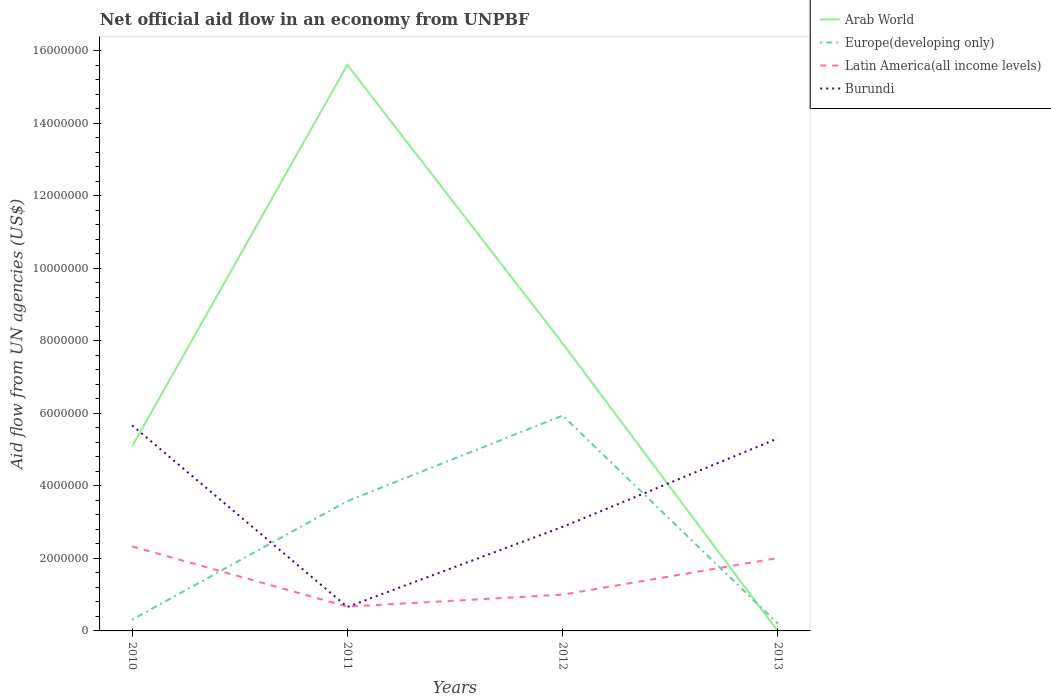Across all years, what is the maximum net official aid flow in Burundi?
Offer a terse response. 6.60e+05. What is the total net official aid flow in Arab World in the graph?
Ensure brevity in your answer.  7.68e+06. What is the difference between the highest and the second highest net official aid flow in Latin America(all income levels)?
Give a very brief answer. 1.66e+06. Is the net official aid flow in Burundi strictly greater than the net official aid flow in Latin America(all income levels) over the years?
Offer a very short reply. No. How many years are there in the graph?
Make the answer very short. 4. Where does the legend appear in the graph?
Keep it short and to the point. Top right. What is the title of the graph?
Provide a short and direct response. Net official aid flow in an economy from UNPBF. What is the label or title of the Y-axis?
Offer a terse response. Aid flow from UN agencies (US$). What is the Aid flow from UN agencies (US$) of Arab World in 2010?
Provide a short and direct response. 5.09e+06. What is the Aid flow from UN agencies (US$) of Europe(developing only) in 2010?
Provide a short and direct response. 3.10e+05. What is the Aid flow from UN agencies (US$) of Latin America(all income levels) in 2010?
Your answer should be very brief. 2.33e+06. What is the Aid flow from UN agencies (US$) of Burundi in 2010?
Your answer should be compact. 5.67e+06. What is the Aid flow from UN agencies (US$) of Arab World in 2011?
Ensure brevity in your answer.  1.56e+07. What is the Aid flow from UN agencies (US$) in Europe(developing only) in 2011?
Keep it short and to the point. 3.58e+06. What is the Aid flow from UN agencies (US$) in Latin America(all income levels) in 2011?
Your answer should be compact. 6.70e+05. What is the Aid flow from UN agencies (US$) of Burundi in 2011?
Give a very brief answer. 6.60e+05. What is the Aid flow from UN agencies (US$) of Arab World in 2012?
Provide a short and direct response. 7.93e+06. What is the Aid flow from UN agencies (US$) in Europe(developing only) in 2012?
Your response must be concise. 5.94e+06. What is the Aid flow from UN agencies (US$) in Latin America(all income levels) in 2012?
Keep it short and to the point. 1.00e+06. What is the Aid flow from UN agencies (US$) of Burundi in 2012?
Your response must be concise. 2.87e+06. What is the Aid flow from UN agencies (US$) of Europe(developing only) in 2013?
Your answer should be very brief. 2.00e+05. What is the Aid flow from UN agencies (US$) of Latin America(all income levels) in 2013?
Your answer should be very brief. 2.01e+06. What is the Aid flow from UN agencies (US$) in Burundi in 2013?
Make the answer very short. 5.31e+06. Across all years, what is the maximum Aid flow from UN agencies (US$) of Arab World?
Provide a succinct answer. 1.56e+07. Across all years, what is the maximum Aid flow from UN agencies (US$) in Europe(developing only)?
Your response must be concise. 5.94e+06. Across all years, what is the maximum Aid flow from UN agencies (US$) in Latin America(all income levels)?
Make the answer very short. 2.33e+06. Across all years, what is the maximum Aid flow from UN agencies (US$) of Burundi?
Keep it short and to the point. 5.67e+06. Across all years, what is the minimum Aid flow from UN agencies (US$) of Latin America(all income levels)?
Ensure brevity in your answer.  6.70e+05. Across all years, what is the minimum Aid flow from UN agencies (US$) in Burundi?
Your answer should be compact. 6.60e+05. What is the total Aid flow from UN agencies (US$) in Arab World in the graph?
Provide a succinct answer. 2.86e+07. What is the total Aid flow from UN agencies (US$) of Europe(developing only) in the graph?
Your answer should be compact. 1.00e+07. What is the total Aid flow from UN agencies (US$) of Latin America(all income levels) in the graph?
Offer a very short reply. 6.01e+06. What is the total Aid flow from UN agencies (US$) in Burundi in the graph?
Offer a very short reply. 1.45e+07. What is the difference between the Aid flow from UN agencies (US$) of Arab World in 2010 and that in 2011?
Your answer should be very brief. -1.05e+07. What is the difference between the Aid flow from UN agencies (US$) in Europe(developing only) in 2010 and that in 2011?
Give a very brief answer. -3.27e+06. What is the difference between the Aid flow from UN agencies (US$) in Latin America(all income levels) in 2010 and that in 2011?
Provide a short and direct response. 1.66e+06. What is the difference between the Aid flow from UN agencies (US$) in Burundi in 2010 and that in 2011?
Provide a succinct answer. 5.01e+06. What is the difference between the Aid flow from UN agencies (US$) of Arab World in 2010 and that in 2012?
Provide a succinct answer. -2.84e+06. What is the difference between the Aid flow from UN agencies (US$) in Europe(developing only) in 2010 and that in 2012?
Your answer should be compact. -5.63e+06. What is the difference between the Aid flow from UN agencies (US$) in Latin America(all income levels) in 2010 and that in 2012?
Your response must be concise. 1.33e+06. What is the difference between the Aid flow from UN agencies (US$) of Burundi in 2010 and that in 2012?
Offer a very short reply. 2.80e+06. What is the difference between the Aid flow from UN agencies (US$) of Europe(developing only) in 2010 and that in 2013?
Your answer should be compact. 1.10e+05. What is the difference between the Aid flow from UN agencies (US$) of Latin America(all income levels) in 2010 and that in 2013?
Provide a succinct answer. 3.20e+05. What is the difference between the Aid flow from UN agencies (US$) of Arab World in 2011 and that in 2012?
Offer a terse response. 7.68e+06. What is the difference between the Aid flow from UN agencies (US$) of Europe(developing only) in 2011 and that in 2012?
Make the answer very short. -2.36e+06. What is the difference between the Aid flow from UN agencies (US$) in Latin America(all income levels) in 2011 and that in 2012?
Your answer should be very brief. -3.30e+05. What is the difference between the Aid flow from UN agencies (US$) in Burundi in 2011 and that in 2012?
Ensure brevity in your answer.  -2.21e+06. What is the difference between the Aid flow from UN agencies (US$) of Europe(developing only) in 2011 and that in 2013?
Make the answer very short. 3.38e+06. What is the difference between the Aid flow from UN agencies (US$) of Latin America(all income levels) in 2011 and that in 2013?
Give a very brief answer. -1.34e+06. What is the difference between the Aid flow from UN agencies (US$) in Burundi in 2011 and that in 2013?
Your answer should be compact. -4.65e+06. What is the difference between the Aid flow from UN agencies (US$) in Europe(developing only) in 2012 and that in 2013?
Offer a terse response. 5.74e+06. What is the difference between the Aid flow from UN agencies (US$) in Latin America(all income levels) in 2012 and that in 2013?
Your answer should be very brief. -1.01e+06. What is the difference between the Aid flow from UN agencies (US$) in Burundi in 2012 and that in 2013?
Your answer should be compact. -2.44e+06. What is the difference between the Aid flow from UN agencies (US$) in Arab World in 2010 and the Aid flow from UN agencies (US$) in Europe(developing only) in 2011?
Your answer should be compact. 1.51e+06. What is the difference between the Aid flow from UN agencies (US$) in Arab World in 2010 and the Aid flow from UN agencies (US$) in Latin America(all income levels) in 2011?
Provide a succinct answer. 4.42e+06. What is the difference between the Aid flow from UN agencies (US$) of Arab World in 2010 and the Aid flow from UN agencies (US$) of Burundi in 2011?
Your answer should be very brief. 4.43e+06. What is the difference between the Aid flow from UN agencies (US$) in Europe(developing only) in 2010 and the Aid flow from UN agencies (US$) in Latin America(all income levels) in 2011?
Give a very brief answer. -3.60e+05. What is the difference between the Aid flow from UN agencies (US$) of Europe(developing only) in 2010 and the Aid flow from UN agencies (US$) of Burundi in 2011?
Offer a very short reply. -3.50e+05. What is the difference between the Aid flow from UN agencies (US$) of Latin America(all income levels) in 2010 and the Aid flow from UN agencies (US$) of Burundi in 2011?
Offer a very short reply. 1.67e+06. What is the difference between the Aid flow from UN agencies (US$) of Arab World in 2010 and the Aid flow from UN agencies (US$) of Europe(developing only) in 2012?
Give a very brief answer. -8.50e+05. What is the difference between the Aid flow from UN agencies (US$) of Arab World in 2010 and the Aid flow from UN agencies (US$) of Latin America(all income levels) in 2012?
Offer a very short reply. 4.09e+06. What is the difference between the Aid flow from UN agencies (US$) in Arab World in 2010 and the Aid flow from UN agencies (US$) in Burundi in 2012?
Offer a terse response. 2.22e+06. What is the difference between the Aid flow from UN agencies (US$) of Europe(developing only) in 2010 and the Aid flow from UN agencies (US$) of Latin America(all income levels) in 2012?
Offer a terse response. -6.90e+05. What is the difference between the Aid flow from UN agencies (US$) of Europe(developing only) in 2010 and the Aid flow from UN agencies (US$) of Burundi in 2012?
Offer a terse response. -2.56e+06. What is the difference between the Aid flow from UN agencies (US$) in Latin America(all income levels) in 2010 and the Aid flow from UN agencies (US$) in Burundi in 2012?
Provide a succinct answer. -5.40e+05. What is the difference between the Aid flow from UN agencies (US$) of Arab World in 2010 and the Aid flow from UN agencies (US$) of Europe(developing only) in 2013?
Your response must be concise. 4.89e+06. What is the difference between the Aid flow from UN agencies (US$) of Arab World in 2010 and the Aid flow from UN agencies (US$) of Latin America(all income levels) in 2013?
Ensure brevity in your answer.  3.08e+06. What is the difference between the Aid flow from UN agencies (US$) of Arab World in 2010 and the Aid flow from UN agencies (US$) of Burundi in 2013?
Your response must be concise. -2.20e+05. What is the difference between the Aid flow from UN agencies (US$) in Europe(developing only) in 2010 and the Aid flow from UN agencies (US$) in Latin America(all income levels) in 2013?
Your answer should be compact. -1.70e+06. What is the difference between the Aid flow from UN agencies (US$) of Europe(developing only) in 2010 and the Aid flow from UN agencies (US$) of Burundi in 2013?
Your answer should be compact. -5.00e+06. What is the difference between the Aid flow from UN agencies (US$) in Latin America(all income levels) in 2010 and the Aid flow from UN agencies (US$) in Burundi in 2013?
Give a very brief answer. -2.98e+06. What is the difference between the Aid flow from UN agencies (US$) of Arab World in 2011 and the Aid flow from UN agencies (US$) of Europe(developing only) in 2012?
Offer a very short reply. 9.67e+06. What is the difference between the Aid flow from UN agencies (US$) in Arab World in 2011 and the Aid flow from UN agencies (US$) in Latin America(all income levels) in 2012?
Ensure brevity in your answer.  1.46e+07. What is the difference between the Aid flow from UN agencies (US$) of Arab World in 2011 and the Aid flow from UN agencies (US$) of Burundi in 2012?
Your answer should be compact. 1.27e+07. What is the difference between the Aid flow from UN agencies (US$) of Europe(developing only) in 2011 and the Aid flow from UN agencies (US$) of Latin America(all income levels) in 2012?
Make the answer very short. 2.58e+06. What is the difference between the Aid flow from UN agencies (US$) in Europe(developing only) in 2011 and the Aid flow from UN agencies (US$) in Burundi in 2012?
Your answer should be very brief. 7.10e+05. What is the difference between the Aid flow from UN agencies (US$) of Latin America(all income levels) in 2011 and the Aid flow from UN agencies (US$) of Burundi in 2012?
Offer a very short reply. -2.20e+06. What is the difference between the Aid flow from UN agencies (US$) in Arab World in 2011 and the Aid flow from UN agencies (US$) in Europe(developing only) in 2013?
Make the answer very short. 1.54e+07. What is the difference between the Aid flow from UN agencies (US$) of Arab World in 2011 and the Aid flow from UN agencies (US$) of Latin America(all income levels) in 2013?
Provide a succinct answer. 1.36e+07. What is the difference between the Aid flow from UN agencies (US$) in Arab World in 2011 and the Aid flow from UN agencies (US$) in Burundi in 2013?
Make the answer very short. 1.03e+07. What is the difference between the Aid flow from UN agencies (US$) of Europe(developing only) in 2011 and the Aid flow from UN agencies (US$) of Latin America(all income levels) in 2013?
Your answer should be very brief. 1.57e+06. What is the difference between the Aid flow from UN agencies (US$) of Europe(developing only) in 2011 and the Aid flow from UN agencies (US$) of Burundi in 2013?
Provide a short and direct response. -1.73e+06. What is the difference between the Aid flow from UN agencies (US$) in Latin America(all income levels) in 2011 and the Aid flow from UN agencies (US$) in Burundi in 2013?
Offer a terse response. -4.64e+06. What is the difference between the Aid flow from UN agencies (US$) of Arab World in 2012 and the Aid flow from UN agencies (US$) of Europe(developing only) in 2013?
Provide a short and direct response. 7.73e+06. What is the difference between the Aid flow from UN agencies (US$) of Arab World in 2012 and the Aid flow from UN agencies (US$) of Latin America(all income levels) in 2013?
Ensure brevity in your answer.  5.92e+06. What is the difference between the Aid flow from UN agencies (US$) of Arab World in 2012 and the Aid flow from UN agencies (US$) of Burundi in 2013?
Make the answer very short. 2.62e+06. What is the difference between the Aid flow from UN agencies (US$) in Europe(developing only) in 2012 and the Aid flow from UN agencies (US$) in Latin America(all income levels) in 2013?
Your answer should be very brief. 3.93e+06. What is the difference between the Aid flow from UN agencies (US$) of Europe(developing only) in 2012 and the Aid flow from UN agencies (US$) of Burundi in 2013?
Give a very brief answer. 6.30e+05. What is the difference between the Aid flow from UN agencies (US$) in Latin America(all income levels) in 2012 and the Aid flow from UN agencies (US$) in Burundi in 2013?
Offer a terse response. -4.31e+06. What is the average Aid flow from UN agencies (US$) of Arab World per year?
Your response must be concise. 7.16e+06. What is the average Aid flow from UN agencies (US$) in Europe(developing only) per year?
Provide a succinct answer. 2.51e+06. What is the average Aid flow from UN agencies (US$) in Latin America(all income levels) per year?
Offer a very short reply. 1.50e+06. What is the average Aid flow from UN agencies (US$) in Burundi per year?
Make the answer very short. 3.63e+06. In the year 2010, what is the difference between the Aid flow from UN agencies (US$) of Arab World and Aid flow from UN agencies (US$) of Europe(developing only)?
Your answer should be compact. 4.78e+06. In the year 2010, what is the difference between the Aid flow from UN agencies (US$) of Arab World and Aid flow from UN agencies (US$) of Latin America(all income levels)?
Keep it short and to the point. 2.76e+06. In the year 2010, what is the difference between the Aid flow from UN agencies (US$) in Arab World and Aid flow from UN agencies (US$) in Burundi?
Ensure brevity in your answer.  -5.80e+05. In the year 2010, what is the difference between the Aid flow from UN agencies (US$) of Europe(developing only) and Aid flow from UN agencies (US$) of Latin America(all income levels)?
Your response must be concise. -2.02e+06. In the year 2010, what is the difference between the Aid flow from UN agencies (US$) in Europe(developing only) and Aid flow from UN agencies (US$) in Burundi?
Your answer should be compact. -5.36e+06. In the year 2010, what is the difference between the Aid flow from UN agencies (US$) in Latin America(all income levels) and Aid flow from UN agencies (US$) in Burundi?
Provide a succinct answer. -3.34e+06. In the year 2011, what is the difference between the Aid flow from UN agencies (US$) in Arab World and Aid flow from UN agencies (US$) in Europe(developing only)?
Provide a short and direct response. 1.20e+07. In the year 2011, what is the difference between the Aid flow from UN agencies (US$) of Arab World and Aid flow from UN agencies (US$) of Latin America(all income levels)?
Make the answer very short. 1.49e+07. In the year 2011, what is the difference between the Aid flow from UN agencies (US$) in Arab World and Aid flow from UN agencies (US$) in Burundi?
Your answer should be compact. 1.50e+07. In the year 2011, what is the difference between the Aid flow from UN agencies (US$) of Europe(developing only) and Aid flow from UN agencies (US$) of Latin America(all income levels)?
Make the answer very short. 2.91e+06. In the year 2011, what is the difference between the Aid flow from UN agencies (US$) of Europe(developing only) and Aid flow from UN agencies (US$) of Burundi?
Your answer should be very brief. 2.92e+06. In the year 2012, what is the difference between the Aid flow from UN agencies (US$) of Arab World and Aid flow from UN agencies (US$) of Europe(developing only)?
Your answer should be compact. 1.99e+06. In the year 2012, what is the difference between the Aid flow from UN agencies (US$) of Arab World and Aid flow from UN agencies (US$) of Latin America(all income levels)?
Offer a very short reply. 6.93e+06. In the year 2012, what is the difference between the Aid flow from UN agencies (US$) of Arab World and Aid flow from UN agencies (US$) of Burundi?
Keep it short and to the point. 5.06e+06. In the year 2012, what is the difference between the Aid flow from UN agencies (US$) of Europe(developing only) and Aid flow from UN agencies (US$) of Latin America(all income levels)?
Offer a terse response. 4.94e+06. In the year 2012, what is the difference between the Aid flow from UN agencies (US$) in Europe(developing only) and Aid flow from UN agencies (US$) in Burundi?
Your answer should be compact. 3.07e+06. In the year 2012, what is the difference between the Aid flow from UN agencies (US$) in Latin America(all income levels) and Aid flow from UN agencies (US$) in Burundi?
Provide a succinct answer. -1.87e+06. In the year 2013, what is the difference between the Aid flow from UN agencies (US$) in Europe(developing only) and Aid flow from UN agencies (US$) in Latin America(all income levels)?
Provide a short and direct response. -1.81e+06. In the year 2013, what is the difference between the Aid flow from UN agencies (US$) of Europe(developing only) and Aid flow from UN agencies (US$) of Burundi?
Offer a terse response. -5.11e+06. In the year 2013, what is the difference between the Aid flow from UN agencies (US$) in Latin America(all income levels) and Aid flow from UN agencies (US$) in Burundi?
Provide a succinct answer. -3.30e+06. What is the ratio of the Aid flow from UN agencies (US$) of Arab World in 2010 to that in 2011?
Provide a short and direct response. 0.33. What is the ratio of the Aid flow from UN agencies (US$) in Europe(developing only) in 2010 to that in 2011?
Provide a short and direct response. 0.09. What is the ratio of the Aid flow from UN agencies (US$) in Latin America(all income levels) in 2010 to that in 2011?
Ensure brevity in your answer.  3.48. What is the ratio of the Aid flow from UN agencies (US$) of Burundi in 2010 to that in 2011?
Your response must be concise. 8.59. What is the ratio of the Aid flow from UN agencies (US$) in Arab World in 2010 to that in 2012?
Keep it short and to the point. 0.64. What is the ratio of the Aid flow from UN agencies (US$) of Europe(developing only) in 2010 to that in 2012?
Your answer should be compact. 0.05. What is the ratio of the Aid flow from UN agencies (US$) in Latin America(all income levels) in 2010 to that in 2012?
Keep it short and to the point. 2.33. What is the ratio of the Aid flow from UN agencies (US$) in Burundi in 2010 to that in 2012?
Keep it short and to the point. 1.98. What is the ratio of the Aid flow from UN agencies (US$) in Europe(developing only) in 2010 to that in 2013?
Provide a short and direct response. 1.55. What is the ratio of the Aid flow from UN agencies (US$) of Latin America(all income levels) in 2010 to that in 2013?
Offer a terse response. 1.16. What is the ratio of the Aid flow from UN agencies (US$) in Burundi in 2010 to that in 2013?
Provide a short and direct response. 1.07. What is the ratio of the Aid flow from UN agencies (US$) of Arab World in 2011 to that in 2012?
Provide a short and direct response. 1.97. What is the ratio of the Aid flow from UN agencies (US$) of Europe(developing only) in 2011 to that in 2012?
Ensure brevity in your answer.  0.6. What is the ratio of the Aid flow from UN agencies (US$) in Latin America(all income levels) in 2011 to that in 2012?
Offer a terse response. 0.67. What is the ratio of the Aid flow from UN agencies (US$) of Burundi in 2011 to that in 2012?
Your answer should be very brief. 0.23. What is the ratio of the Aid flow from UN agencies (US$) in Europe(developing only) in 2011 to that in 2013?
Keep it short and to the point. 17.9. What is the ratio of the Aid flow from UN agencies (US$) in Burundi in 2011 to that in 2013?
Provide a succinct answer. 0.12. What is the ratio of the Aid flow from UN agencies (US$) in Europe(developing only) in 2012 to that in 2013?
Make the answer very short. 29.7. What is the ratio of the Aid flow from UN agencies (US$) in Latin America(all income levels) in 2012 to that in 2013?
Ensure brevity in your answer.  0.5. What is the ratio of the Aid flow from UN agencies (US$) in Burundi in 2012 to that in 2013?
Provide a short and direct response. 0.54. What is the difference between the highest and the second highest Aid flow from UN agencies (US$) in Arab World?
Offer a very short reply. 7.68e+06. What is the difference between the highest and the second highest Aid flow from UN agencies (US$) of Europe(developing only)?
Provide a short and direct response. 2.36e+06. What is the difference between the highest and the lowest Aid flow from UN agencies (US$) in Arab World?
Give a very brief answer. 1.56e+07. What is the difference between the highest and the lowest Aid flow from UN agencies (US$) of Europe(developing only)?
Offer a very short reply. 5.74e+06. What is the difference between the highest and the lowest Aid flow from UN agencies (US$) in Latin America(all income levels)?
Your answer should be compact. 1.66e+06. What is the difference between the highest and the lowest Aid flow from UN agencies (US$) in Burundi?
Your answer should be very brief. 5.01e+06. 